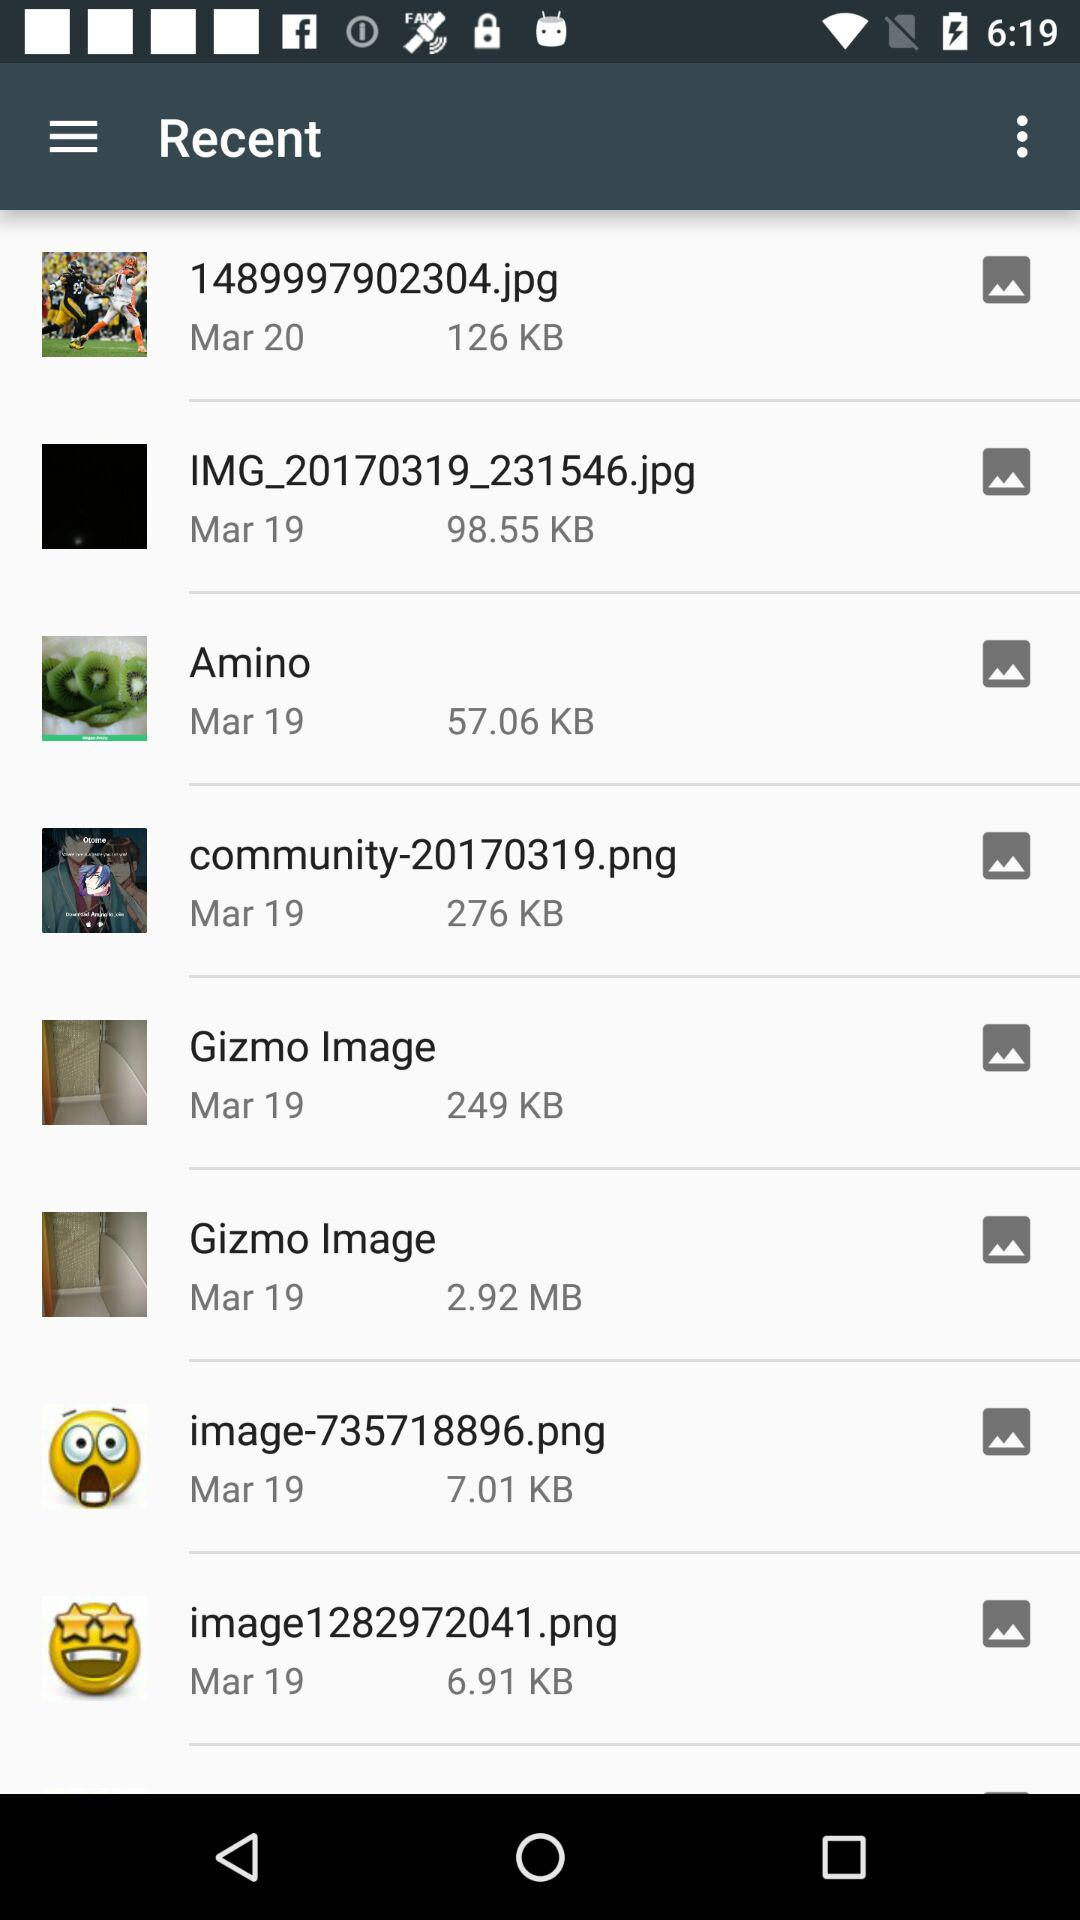How many KB are there in the "Gizmo Image" photo? There are 249 KB in the "Gizmo Image" photo. 